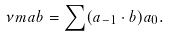<formula> <loc_0><loc_0><loc_500><loc_500>\nu m a b = \sum ( a _ { - 1 } \cdot b ) a _ { 0 } .</formula> 